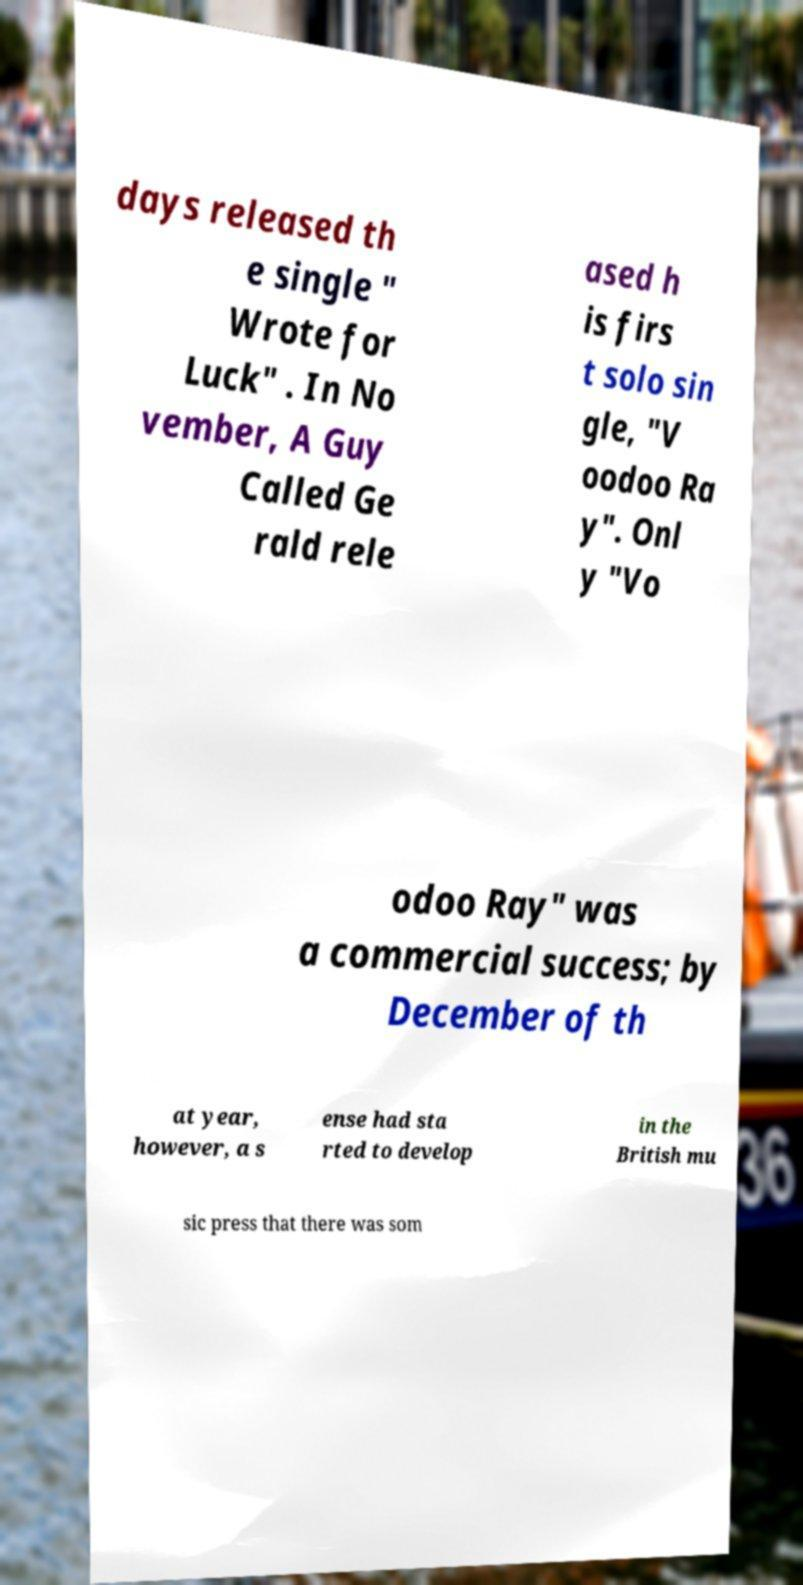There's text embedded in this image that I need extracted. Can you transcribe it verbatim? days released th e single " Wrote for Luck" . In No vember, A Guy Called Ge rald rele ased h is firs t solo sin gle, "V oodoo Ra y". Onl y "Vo odoo Ray" was a commercial success; by December of th at year, however, a s ense had sta rted to develop in the British mu sic press that there was som 